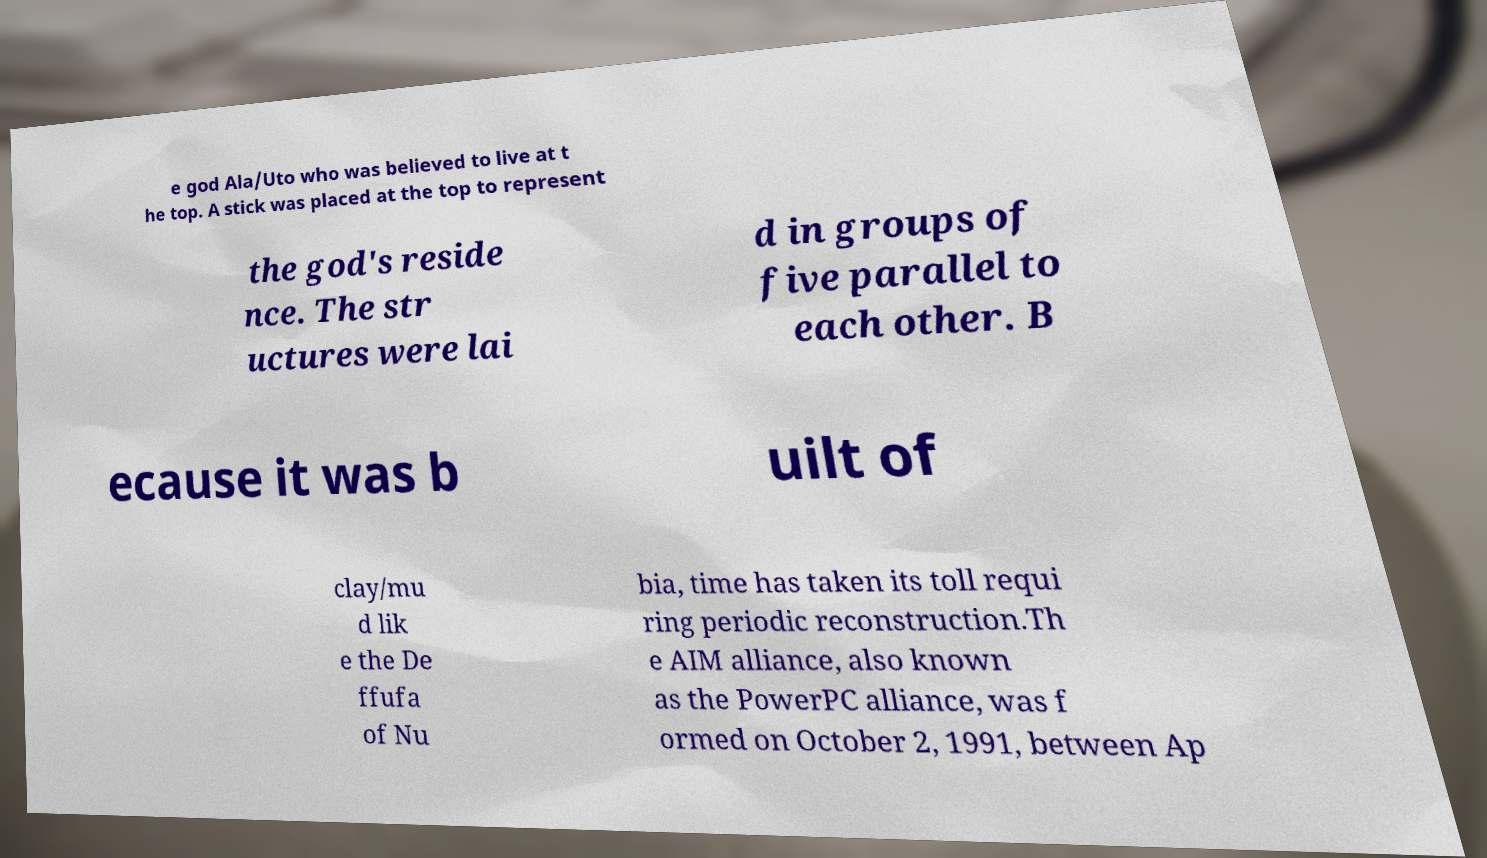I need the written content from this picture converted into text. Can you do that? e god Ala/Uto who was believed to live at t he top. A stick was placed at the top to represent the god's reside nce. The str uctures were lai d in groups of five parallel to each other. B ecause it was b uilt of clay/mu d lik e the De ffufa of Nu bia, time has taken its toll requi ring periodic reconstruction.Th e AIM alliance, also known as the PowerPC alliance, was f ormed on October 2, 1991, between Ap 